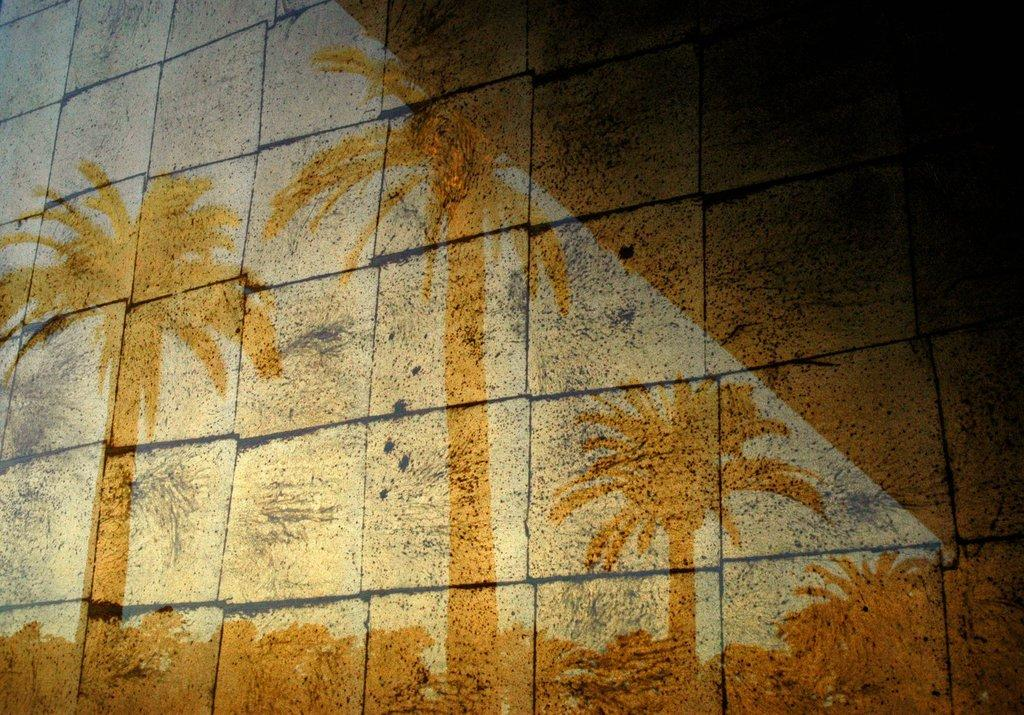What type of vegetation is responsible for the shadow in the image? The shadow of palm trees is visible in the image. On what surface is the shadow cast? The shadow is cast on a wall. What is the texture of the wall? The wall has large bricks. What color are the lines between the bricks? There are black lines between the bricks. What type of journey does the bear take in the image? There is no bear present in the image, so it is not possible to discuss a journey. 